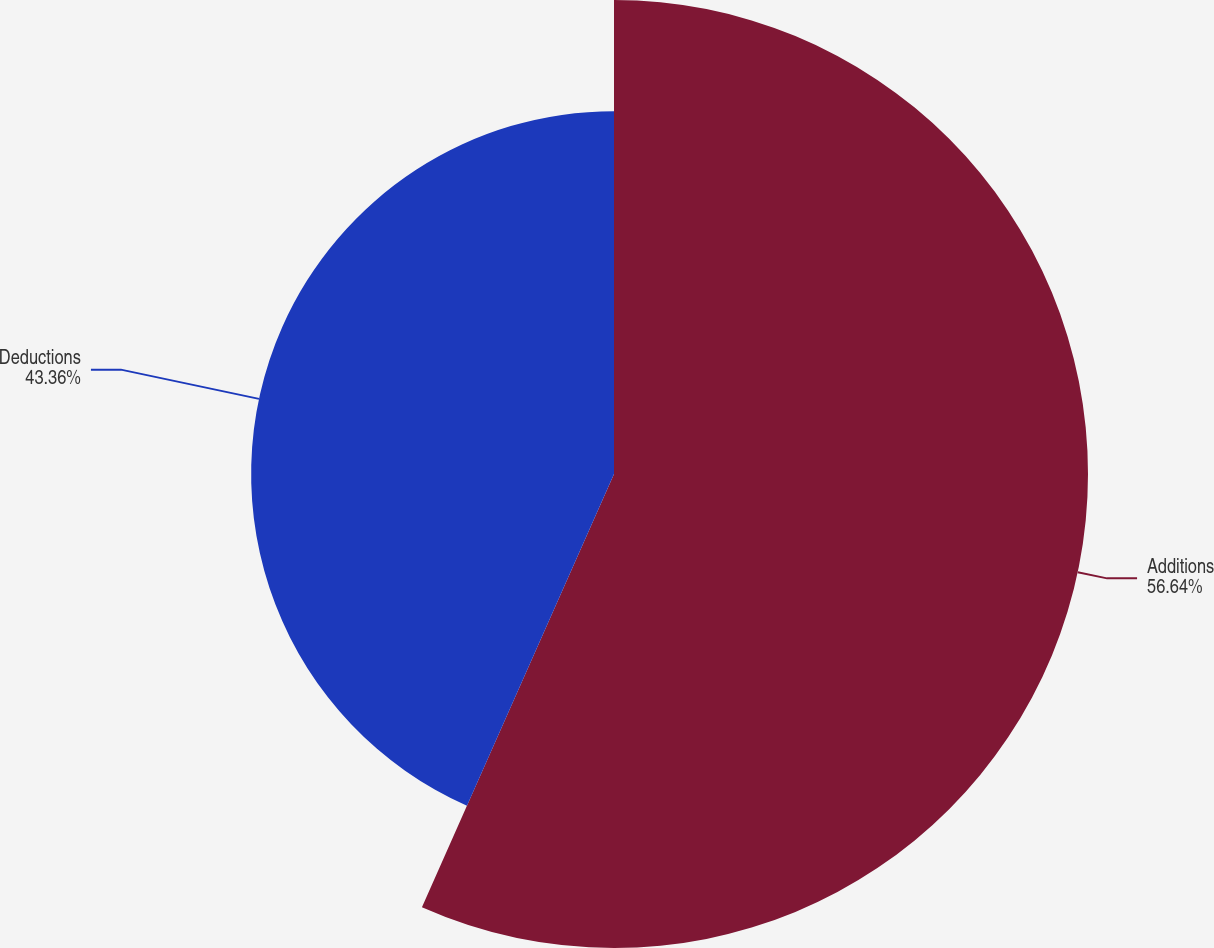Convert chart to OTSL. <chart><loc_0><loc_0><loc_500><loc_500><pie_chart><fcel>Additions<fcel>Deductions<nl><fcel>56.64%<fcel>43.36%<nl></chart> 